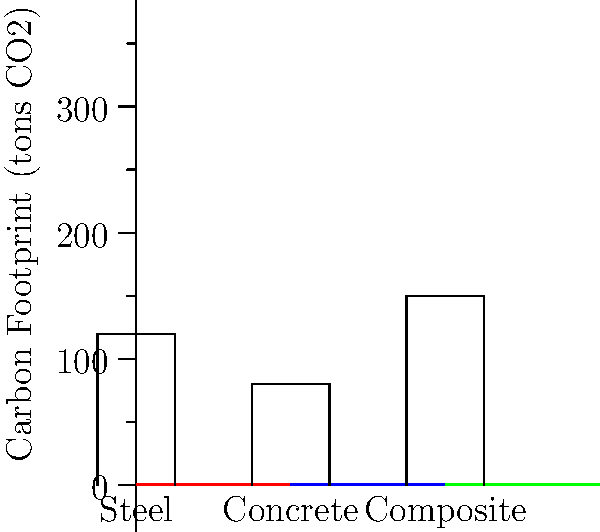As an environmentalist concerned about the carbon footprint of local infrastructure projects, you're analyzing different bridge designs for a new crossing in Rafter's constituency. Based on the bar graph showing the carbon footprint (in tons of CO2) for three bridge types, which design would you recommend to minimize environmental impact, and by how many tons of CO2 would it reduce emissions compared to the highest-emitting option? To answer this question, we need to follow these steps:

1. Identify the carbon footprint for each bridge type from the graph:
   - Steel: 120 tons CO2
   - Concrete: 80 tons CO2
   - Composite: 150 tons CO2

2. Determine the bridge type with the lowest carbon footprint:
   Concrete has the lowest at 80 tons CO2.

3. Identify the bridge type with the highest carbon footprint:
   Composite has the highest at 150 tons CO2.

4. Calculate the difference in emissions between the highest and lowest options:
   $$150 \text{ tons CO2} - 80 \text{ tons CO2} = 70 \text{ tons CO2}$$

Therefore, as an environmentalist, you would recommend the Concrete bridge design, as it would reduce emissions by 70 tons of CO2 compared to the highest-emitting Composite design.
Answer: Concrete bridge; 70 tons CO2 reduction 